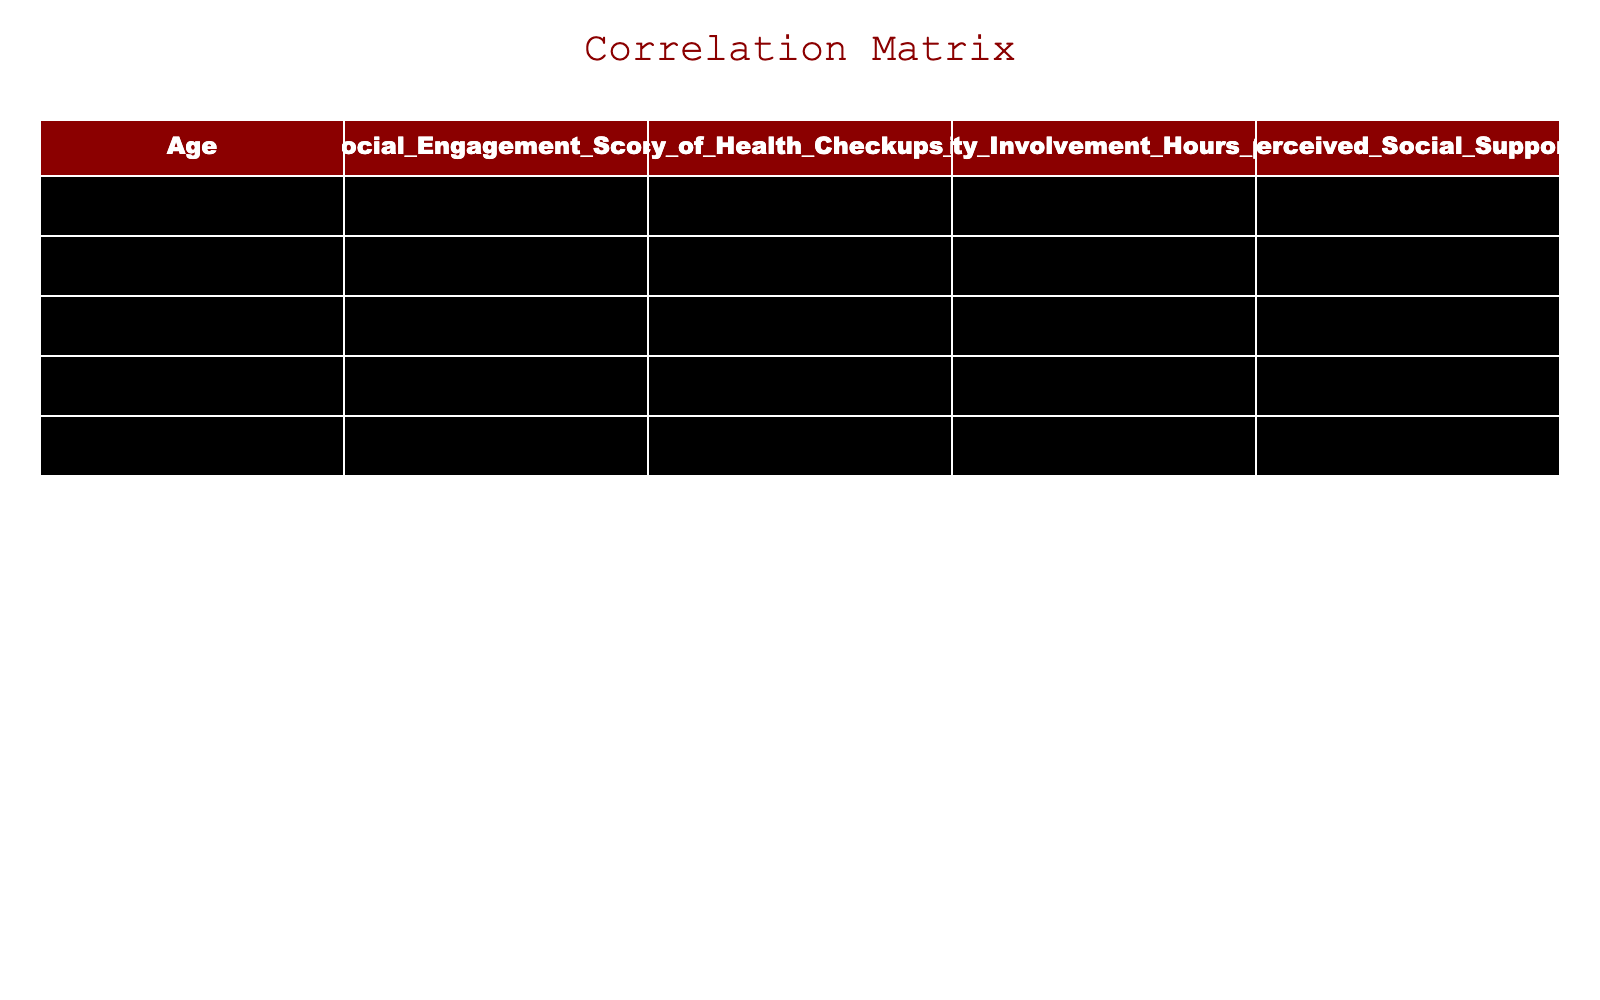What is the correlation coefficient between social engagement score and frequency of health check-ups? By examining the correlation table, we see the value in the cell representing the relationship between social engagement score and frequency of health check-ups, which is approximately 0.60. This indicates a moderate positive correlation.
Answer: 0.60 Is there a strong correlation between community involvement hours per week and the perceived social support? From the correlation table, we find the correlation coefficient between community involvement hours and perceived social support is 0.80, which suggests a strong positive relationship between these two variables.
Answer: Yes What are the community involvement hours for the oldest individual in the dataset? The oldest individual, who is 80 years old, has 0 community involvement hours per week, as observed directly from the row corresponding to the age of 80.
Answer: 0 What is the average frequency of health check-ups among individuals with a social engagement score of 5 or lower? We look at the individuals with a social engagement score of 5 or less: ages 75 and 80, both having frequencies of 1 and 1 respectively. The average frequency of health check-ups is (1 + 1) / 2 = 1.
Answer: 1 Does an increase in social engagement score tend to relate to an increased frequency of health check-ups? The correlation coefficient between social engagement score and frequency of health check-ups is 0.60, indicating that as social engagement increases, the frequency of health check-ups tends to increase as well. This supports a positive association.
Answer: Yes What is the maximum social engagement score recorded in the table? Scanning through the social engagement scores, the highest value is 10, which is associated with the individual aged 70.
Answer: 10 How many individuals have a frequency of health check-ups greater than 2? The table indicates that there are two individuals (ages 72 and 70) whose frequency of health check-ups is greater than 2 (3 and 4 respectively).
Answer: 2 What is the sum of perceived social support for all individuals with a social engagement score below 6? We identify individuals with scores below 6: ages 75, 80, 74, and 73, with perceived social support values of 5, 4, 3, and 6 respectively. The sum is 5 + 4 + 3 + 6 = 18.
Answer: 18 What is the relationship between age and frequency of health check-ups based on the table? Observing the correlation coefficient between age and frequency of health check-ups in the table, we note it is -0.40, which indicates a moderate negative correlation. This suggests that as age increases, the frequency of health check-ups tends to decrease.
Answer: -0.40 